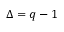<formula> <loc_0><loc_0><loc_500><loc_500>\Delta = q - 1</formula> 